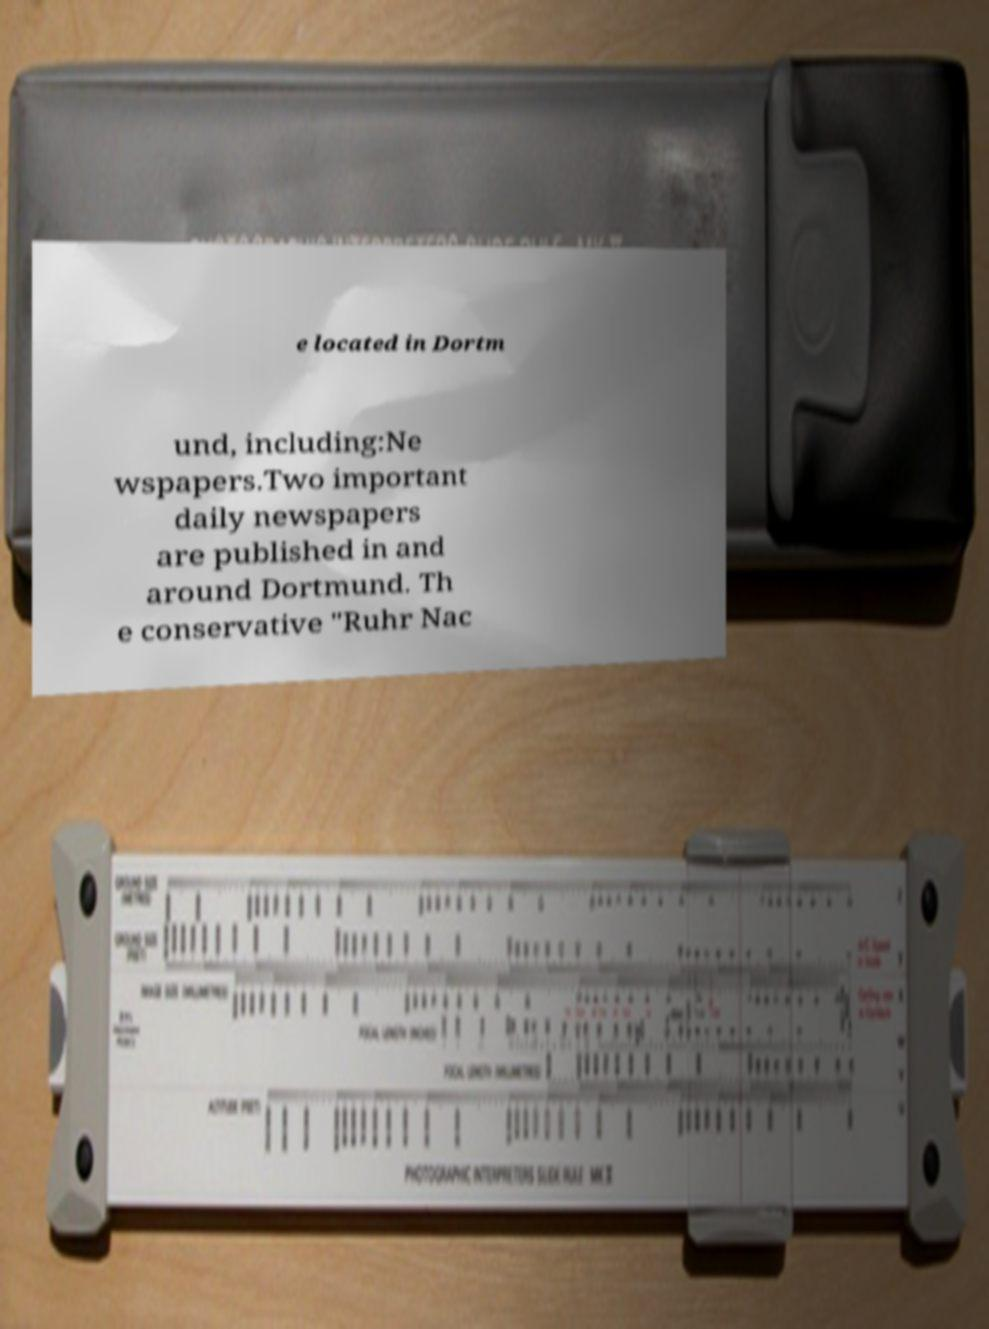For documentation purposes, I need the text within this image transcribed. Could you provide that? e located in Dortm und, including:Ne wspapers.Two important daily newspapers are published in and around Dortmund. Th e conservative "Ruhr Nac 